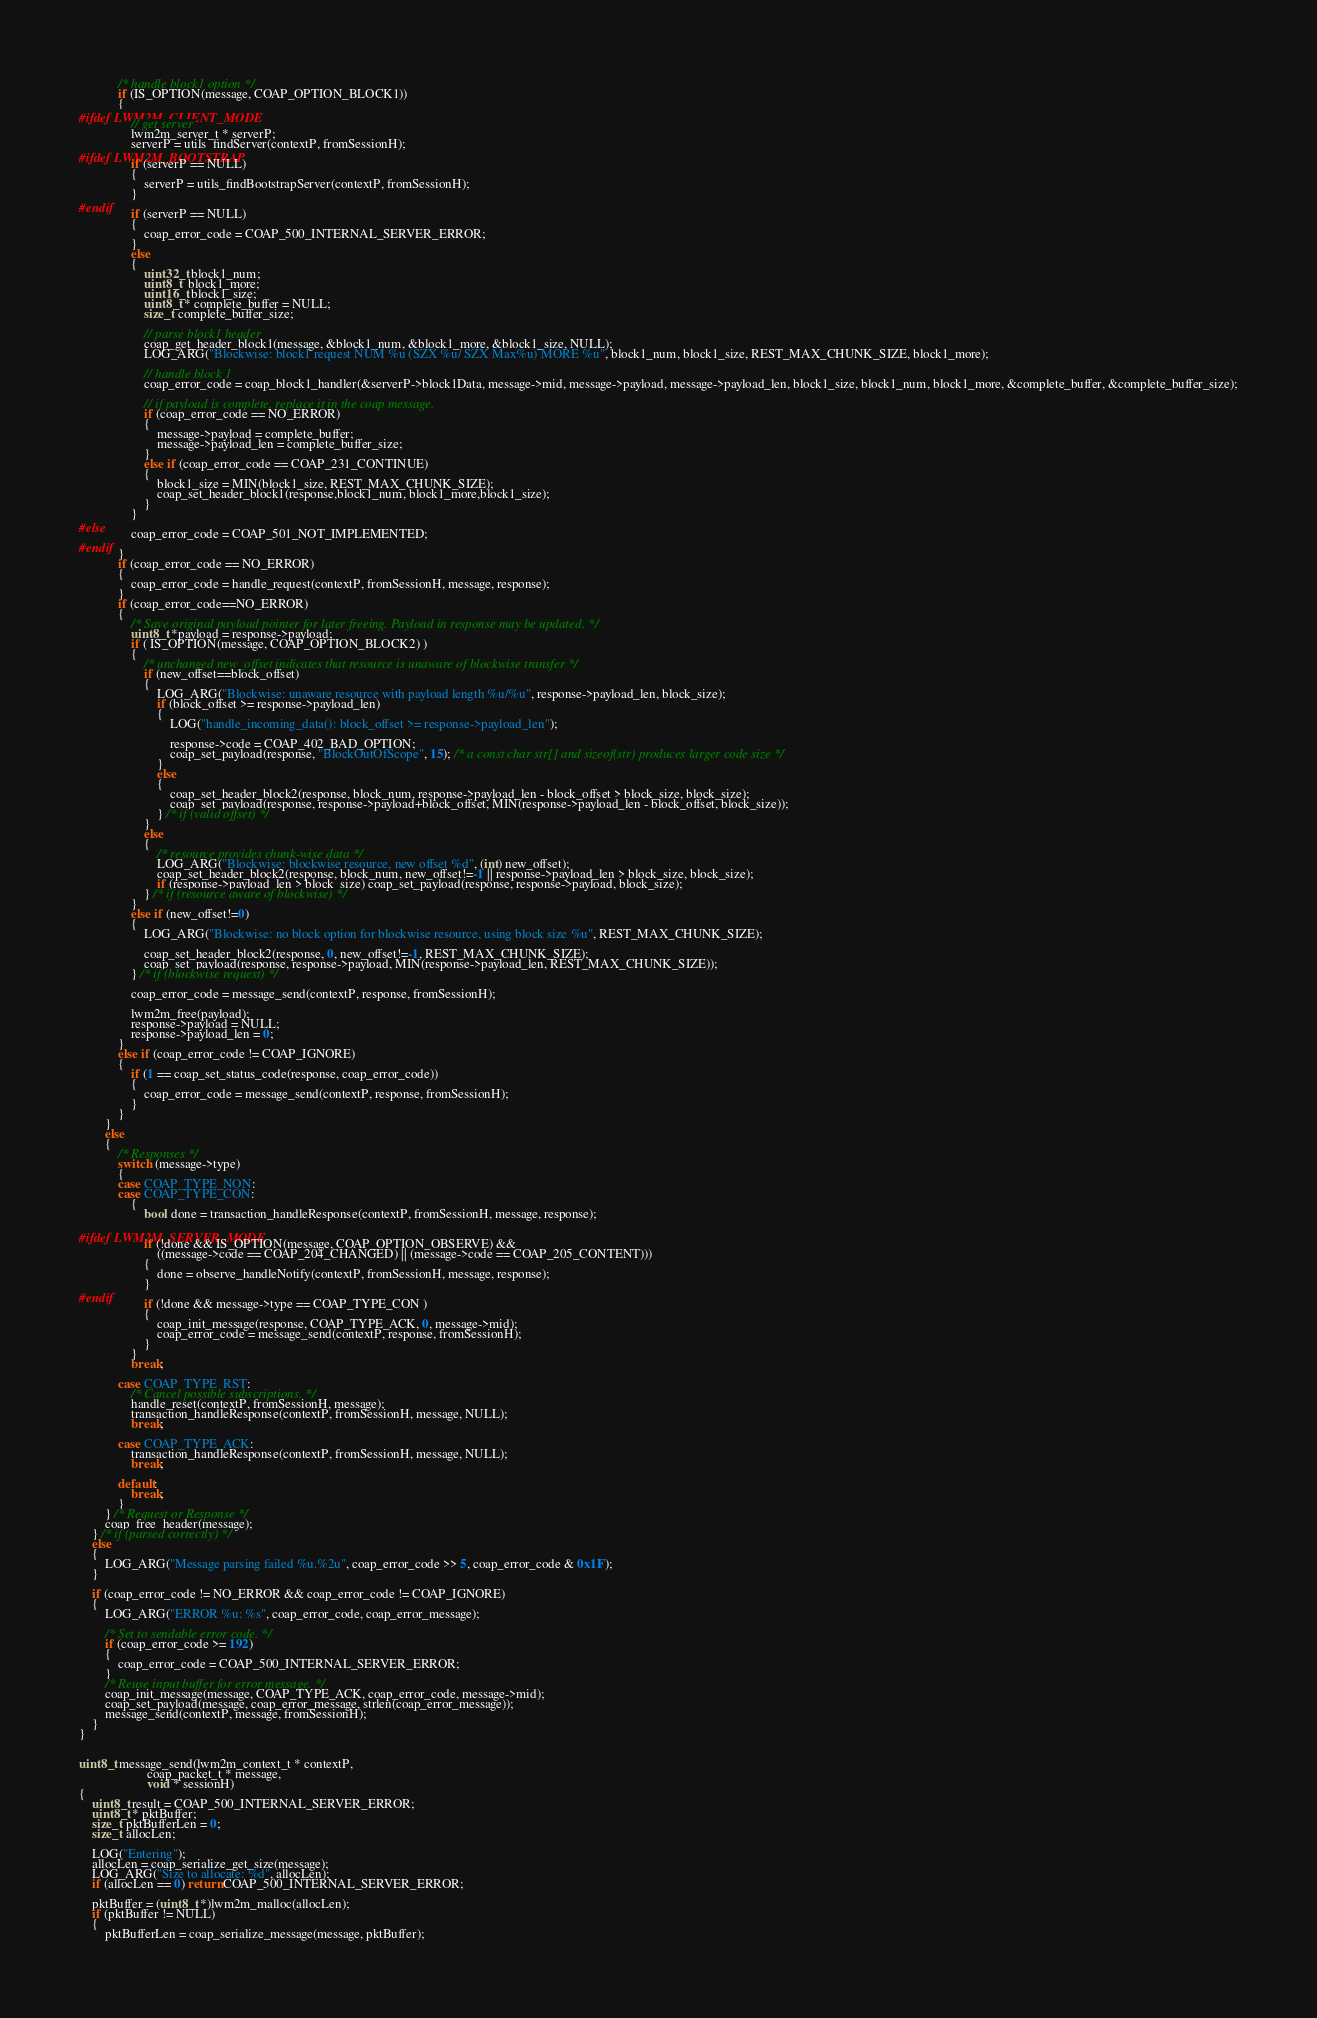Convert code to text. <code><loc_0><loc_0><loc_500><loc_500><_C_>            /* handle block1 option */
            if (IS_OPTION(message, COAP_OPTION_BLOCK1))
            {
#ifdef LWM2M_CLIENT_MODE
                // get server
                lwm2m_server_t * serverP;
                serverP = utils_findServer(contextP, fromSessionH);
#ifdef LWM2M_BOOTSTRAP
                if (serverP == NULL)
                {
                    serverP = utils_findBootstrapServer(contextP, fromSessionH);
                }
#endif
                if (serverP == NULL)
                {
                    coap_error_code = COAP_500_INTERNAL_SERVER_ERROR;
                }
                else
                {
                    uint32_t block1_num;
                    uint8_t  block1_more;
                    uint16_t block1_size;
                    uint8_t * complete_buffer = NULL;
                    size_t complete_buffer_size;

                    // parse block1 header
                    coap_get_header_block1(message, &block1_num, &block1_more, &block1_size, NULL);
                    LOG_ARG("Blockwise: block1 request NUM %u (SZX %u/ SZX Max%u) MORE %u", block1_num, block1_size, REST_MAX_CHUNK_SIZE, block1_more);

                    // handle block 1
                    coap_error_code = coap_block1_handler(&serverP->block1Data, message->mid, message->payload, message->payload_len, block1_size, block1_num, block1_more, &complete_buffer, &complete_buffer_size);

                    // if payload is complete, replace it in the coap message.
                    if (coap_error_code == NO_ERROR)
                    {
                        message->payload = complete_buffer;
                        message->payload_len = complete_buffer_size;
                    }
                    else if (coap_error_code == COAP_231_CONTINUE)
                    {
                        block1_size = MIN(block1_size, REST_MAX_CHUNK_SIZE);
                        coap_set_header_block1(response,block1_num, block1_more,block1_size);
                    }
                }
#else
                coap_error_code = COAP_501_NOT_IMPLEMENTED;
#endif
            }
            if (coap_error_code == NO_ERROR)
            {
                coap_error_code = handle_request(contextP, fromSessionH, message, response);
            }
            if (coap_error_code==NO_ERROR)
            {
                /* Save original payload pointer for later freeing. Payload in response may be updated. */
                uint8_t *payload = response->payload;
                if ( IS_OPTION(message, COAP_OPTION_BLOCK2) )
                {
                    /* unchanged new_offset indicates that resource is unaware of blockwise transfer */
                    if (new_offset==block_offset)
                    {
                        LOG_ARG("Blockwise: unaware resource with payload length %u/%u", response->payload_len, block_size);
                        if (block_offset >= response->payload_len)
                        {
                            LOG("handle_incoming_data(): block_offset >= response->payload_len");

                            response->code = COAP_402_BAD_OPTION;
                            coap_set_payload(response, "BlockOutOfScope", 15); /* a const char str[] and sizeof(str) produces larger code size */
                        }
                        else
                        {
                            coap_set_header_block2(response, block_num, response->payload_len - block_offset > block_size, block_size);
                            coap_set_payload(response, response->payload+block_offset, MIN(response->payload_len - block_offset, block_size));
                        } /* if (valid offset) */
                    }
                    else
                    {
                        /* resource provides chunk-wise data */
                        LOG_ARG("Blockwise: blockwise resource, new offset %d", (int) new_offset);
                        coap_set_header_block2(response, block_num, new_offset!=-1 || response->payload_len > block_size, block_size);
                        if (response->payload_len > block_size) coap_set_payload(response, response->payload, block_size);
                    } /* if (resource aware of blockwise) */
                }
                else if (new_offset!=0)
                {
                    LOG_ARG("Blockwise: no block option for blockwise resource, using block size %u", REST_MAX_CHUNK_SIZE);

                    coap_set_header_block2(response, 0, new_offset!=-1, REST_MAX_CHUNK_SIZE);
                    coap_set_payload(response, response->payload, MIN(response->payload_len, REST_MAX_CHUNK_SIZE));
                } /* if (blockwise request) */

                coap_error_code = message_send(contextP, response, fromSessionH);

                lwm2m_free(payload);
                response->payload = NULL;
                response->payload_len = 0;
            }
            else if (coap_error_code != COAP_IGNORE)
            {
                if (1 == coap_set_status_code(response, coap_error_code))
                {
                    coap_error_code = message_send(contextP, response, fromSessionH);
                }
            }
        }
        else
        {
            /* Responses */
            switch (message->type)
            {
            case COAP_TYPE_NON:
            case COAP_TYPE_CON:
                {
                    bool done = transaction_handleResponse(contextP, fromSessionH, message, response);

#ifdef LWM2M_SERVER_MODE
                    if (!done && IS_OPTION(message, COAP_OPTION_OBSERVE) &&
                        ((message->code == COAP_204_CHANGED) || (message->code == COAP_205_CONTENT)))
                    {
                        done = observe_handleNotify(contextP, fromSessionH, message, response);
                    }
#endif
                    if (!done && message->type == COAP_TYPE_CON )
                    {
                        coap_init_message(response, COAP_TYPE_ACK, 0, message->mid);
                        coap_error_code = message_send(contextP, response, fromSessionH);
                    }
                }
                break;

            case COAP_TYPE_RST:
                /* Cancel possible subscriptions. */
                handle_reset(contextP, fromSessionH, message);
                transaction_handleResponse(contextP, fromSessionH, message, NULL);
                break;

            case COAP_TYPE_ACK:
                transaction_handleResponse(contextP, fromSessionH, message, NULL);
                break;

            default:
                break;
            }
        } /* Request or Response */
        coap_free_header(message);
    } /* if (parsed correctly) */
    else
    {
        LOG_ARG("Message parsing failed %u.%2u", coap_error_code >> 5, coap_error_code & 0x1F);
    }

    if (coap_error_code != NO_ERROR && coap_error_code != COAP_IGNORE)
    {
        LOG_ARG("ERROR %u: %s", coap_error_code, coap_error_message);

        /* Set to sendable error code. */
        if (coap_error_code >= 192)
        {
            coap_error_code = COAP_500_INTERNAL_SERVER_ERROR;
        }
        /* Reuse input buffer for error message. */
        coap_init_message(message, COAP_TYPE_ACK, coap_error_code, message->mid);
        coap_set_payload(message, coap_error_message, strlen(coap_error_message));
        message_send(contextP, message, fromSessionH);
    }
}


uint8_t message_send(lwm2m_context_t * contextP,
                     coap_packet_t * message,
                     void * sessionH)
{
    uint8_t result = COAP_500_INTERNAL_SERVER_ERROR;
    uint8_t * pktBuffer;
    size_t pktBufferLen = 0;
    size_t allocLen;

    LOG("Entering");
    allocLen = coap_serialize_get_size(message);
    LOG_ARG("Size to allocate: %d", allocLen);
    if (allocLen == 0) return COAP_500_INTERNAL_SERVER_ERROR;

    pktBuffer = (uint8_t *)lwm2m_malloc(allocLen);
    if (pktBuffer != NULL)
    {
        pktBufferLen = coap_serialize_message(message, pktBuffer);</code> 